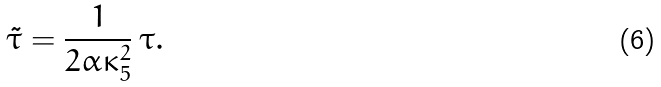<formula> <loc_0><loc_0><loc_500><loc_500>\tilde { \tau } = \frac { 1 } { 2 \alpha \kappa _ { 5 } ^ { 2 } } \, \tau .</formula> 